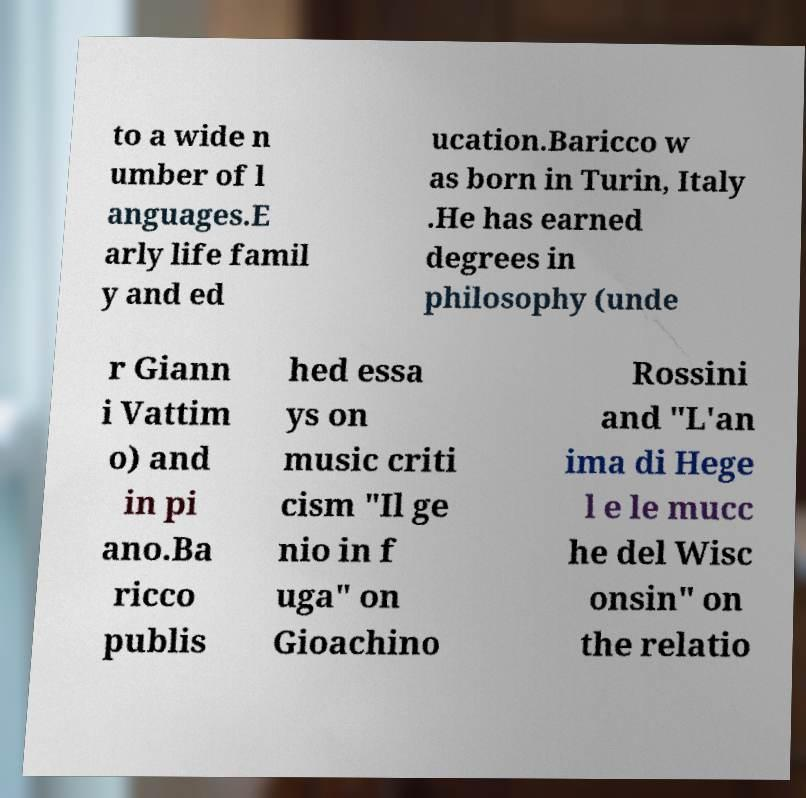Please read and relay the text visible in this image. What does it say? to a wide n umber of l anguages.E arly life famil y and ed ucation.Baricco w as born in Turin, Italy .He has earned degrees in philosophy (unde r Giann i Vattim o) and in pi ano.Ba ricco publis hed essa ys on music criti cism "Il ge nio in f uga" on Gioachino Rossini and "L'an ima di Hege l e le mucc he del Wisc onsin" on the relatio 